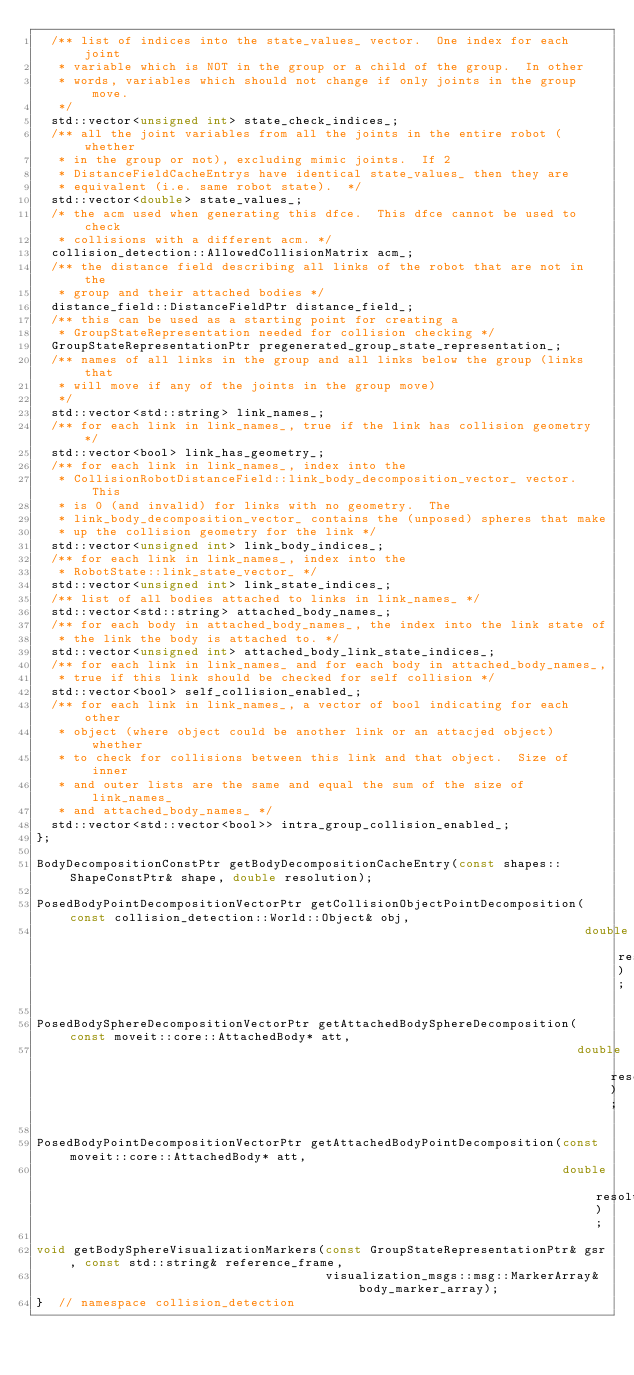Convert code to text. <code><loc_0><loc_0><loc_500><loc_500><_C_>  /** list of indices into the state_values_ vector.  One index for each joint
   * variable which is NOT in the group or a child of the group.  In other
   * words, variables which should not change if only joints in the group move.
   */
  std::vector<unsigned int> state_check_indices_;
  /** all the joint variables from all the joints in the entire robot (whether
   * in the group or not), excluding mimic joints.  If 2
   * DistanceFieldCacheEntrys have identical state_values_ then they are
   * equivalent (i.e. same robot state).  */
  std::vector<double> state_values_;
  /* the acm used when generating this dfce.  This dfce cannot be used to check
   * collisions with a different acm. */
  collision_detection::AllowedCollisionMatrix acm_;
  /** the distance field describing all links of the robot that are not in the
   * group and their attached bodies */
  distance_field::DistanceFieldPtr distance_field_;
  /** this can be used as a starting point for creating a
   * GroupStateRepresentation needed for collision checking */
  GroupStateRepresentationPtr pregenerated_group_state_representation_;
  /** names of all links in the group and all links below the group (links that
   * will move if any of the joints in the group move)
   */
  std::vector<std::string> link_names_;
  /** for each link in link_names_, true if the link has collision geometry */
  std::vector<bool> link_has_geometry_;
  /** for each link in link_names_, index into the
   * CollisionRobotDistanceField::link_body_decomposition_vector_ vector.  This
   * is 0 (and invalid) for links with no geometry.  The
   * link_body_decomposition_vector_ contains the (unposed) spheres that make
   * up the collision geometry for the link */
  std::vector<unsigned int> link_body_indices_;
  /** for each link in link_names_, index into the
   * RobotState::link_state_vector_ */
  std::vector<unsigned int> link_state_indices_;
  /** list of all bodies attached to links in link_names_ */
  std::vector<std::string> attached_body_names_;
  /** for each body in attached_body_names_, the index into the link state of
   * the link the body is attached to. */
  std::vector<unsigned int> attached_body_link_state_indices_;
  /** for each link in link_names_ and for each body in attached_body_names_,
   * true if this link should be checked for self collision */
  std::vector<bool> self_collision_enabled_;
  /** for each link in link_names_, a vector of bool indicating for each other
   * object (where object could be another link or an attacjed object) whether
   * to check for collisions between this link and that object.  Size of inner
   * and outer lists are the same and equal the sum of the size of link_names_
   * and attached_body_names_ */
  std::vector<std::vector<bool>> intra_group_collision_enabled_;
};

BodyDecompositionConstPtr getBodyDecompositionCacheEntry(const shapes::ShapeConstPtr& shape, double resolution);

PosedBodyPointDecompositionVectorPtr getCollisionObjectPointDecomposition(const collision_detection::World::Object& obj,
                                                                          double resolution);

PosedBodySphereDecompositionVectorPtr getAttachedBodySphereDecomposition(const moveit::core::AttachedBody* att,
                                                                         double resolution);

PosedBodyPointDecompositionVectorPtr getAttachedBodyPointDecomposition(const moveit::core::AttachedBody* att,
                                                                       double resolution);

void getBodySphereVisualizationMarkers(const GroupStateRepresentationPtr& gsr, const std::string& reference_frame,
                                       visualization_msgs::msg::MarkerArray& body_marker_array);
}  // namespace collision_detection
</code> 